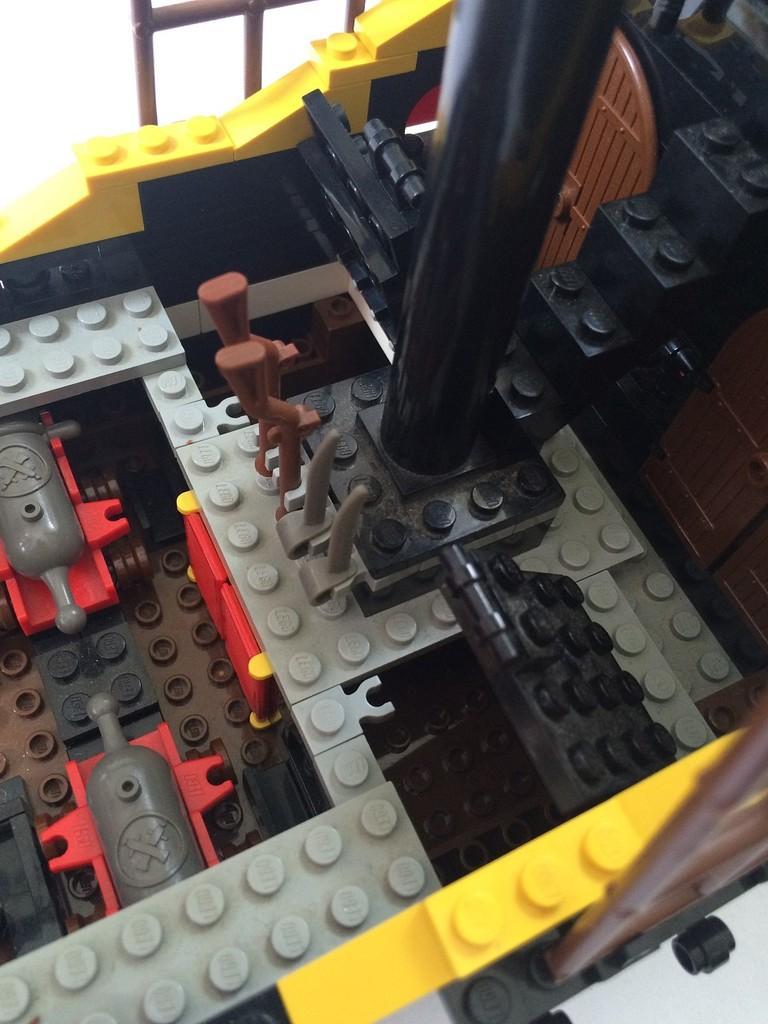Describe this image in one or two sentences. There is a toy made with a building blocks. 